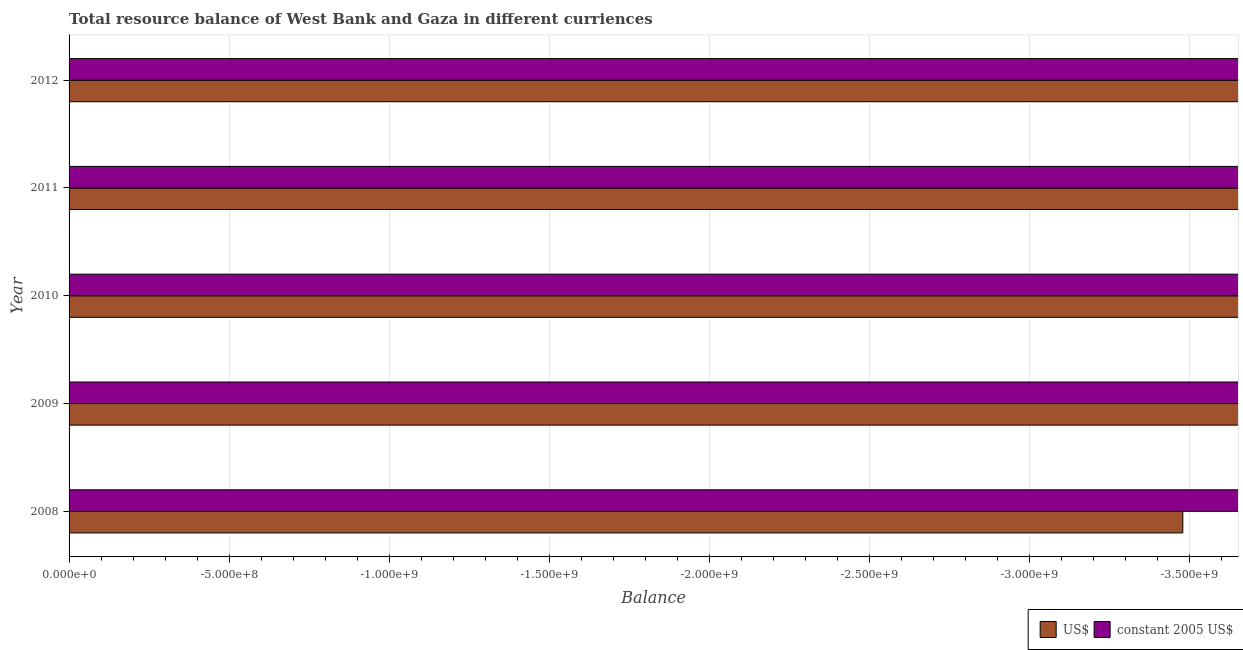Are the number of bars on each tick of the Y-axis equal?
Keep it short and to the point. Yes. In how many cases, is the number of bars for a given year not equal to the number of legend labels?
Make the answer very short. 5. What is the resource balance in us$ in 2012?
Make the answer very short. 0. Across all years, what is the minimum resource balance in us$?
Provide a succinct answer. 0. What is the total resource balance in us$ in the graph?
Make the answer very short. 0. What is the average resource balance in us$ per year?
Give a very brief answer. 0. In how many years, is the resource balance in constant us$ greater than the average resource balance in constant us$ taken over all years?
Offer a very short reply. 0. How many bars are there?
Your answer should be very brief. 0. How many years are there in the graph?
Make the answer very short. 5. What is the difference between two consecutive major ticks on the X-axis?
Provide a succinct answer. 5.00e+08. Are the values on the major ticks of X-axis written in scientific E-notation?
Provide a short and direct response. Yes. Does the graph contain any zero values?
Give a very brief answer. Yes. Where does the legend appear in the graph?
Your answer should be compact. Bottom right. What is the title of the graph?
Your answer should be compact. Total resource balance of West Bank and Gaza in different curriences. What is the label or title of the X-axis?
Provide a succinct answer. Balance. What is the Balance in constant 2005 US$ in 2008?
Ensure brevity in your answer.  0. What is the Balance of US$ in 2010?
Keep it short and to the point. 0. What is the Balance in constant 2005 US$ in 2010?
Offer a terse response. 0. What is the Balance of constant 2005 US$ in 2011?
Offer a very short reply. 0. What is the Balance of US$ in 2012?
Keep it short and to the point. 0. What is the total Balance in US$ in the graph?
Offer a very short reply. 0. What is the average Balance of US$ per year?
Offer a terse response. 0. What is the average Balance of constant 2005 US$ per year?
Provide a short and direct response. 0. 